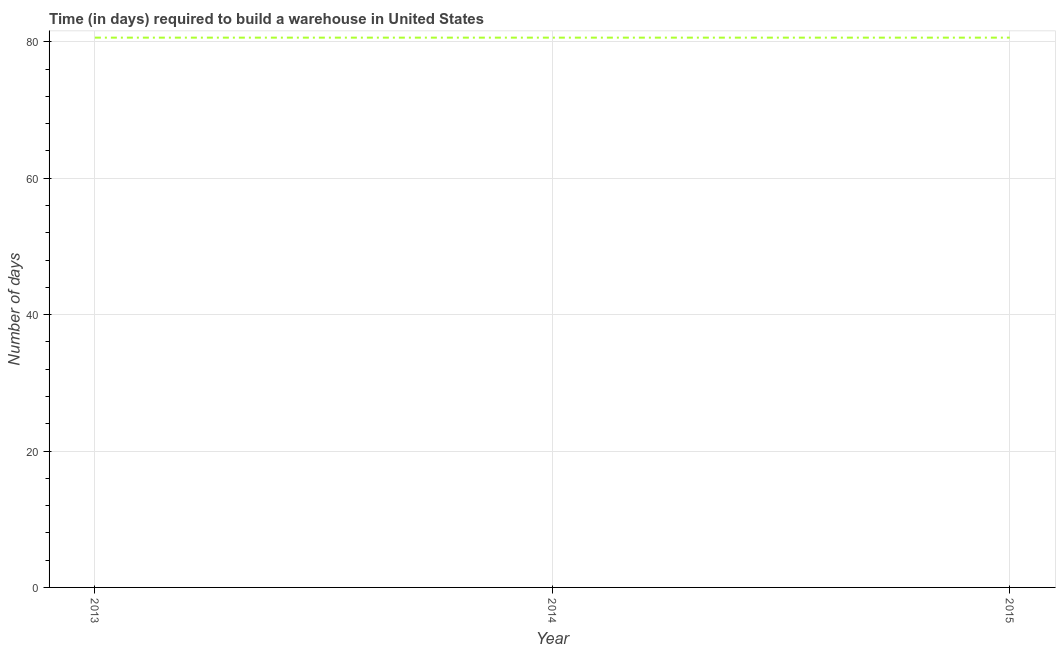What is the time required to build a warehouse in 2014?
Keep it short and to the point. 80.6. Across all years, what is the maximum time required to build a warehouse?
Your response must be concise. 80.6. Across all years, what is the minimum time required to build a warehouse?
Ensure brevity in your answer.  80.6. In which year was the time required to build a warehouse maximum?
Your response must be concise. 2013. What is the sum of the time required to build a warehouse?
Offer a terse response. 241.8. What is the difference between the time required to build a warehouse in 2013 and 2014?
Offer a terse response. 0. What is the average time required to build a warehouse per year?
Offer a very short reply. 80.6. What is the median time required to build a warehouse?
Your answer should be compact. 80.6. What is the difference between the highest and the second highest time required to build a warehouse?
Give a very brief answer. 0. In how many years, is the time required to build a warehouse greater than the average time required to build a warehouse taken over all years?
Make the answer very short. 0. How many lines are there?
Provide a succinct answer. 1. How many years are there in the graph?
Keep it short and to the point. 3. What is the difference between two consecutive major ticks on the Y-axis?
Give a very brief answer. 20. Are the values on the major ticks of Y-axis written in scientific E-notation?
Make the answer very short. No. Does the graph contain any zero values?
Your answer should be compact. No. What is the title of the graph?
Your response must be concise. Time (in days) required to build a warehouse in United States. What is the label or title of the Y-axis?
Offer a terse response. Number of days. What is the Number of days of 2013?
Provide a succinct answer. 80.6. What is the Number of days in 2014?
Your answer should be compact. 80.6. What is the Number of days in 2015?
Your answer should be compact. 80.6. What is the difference between the Number of days in 2013 and 2014?
Provide a short and direct response. 0. What is the difference between the Number of days in 2013 and 2015?
Give a very brief answer. 0. What is the difference between the Number of days in 2014 and 2015?
Offer a terse response. 0. What is the ratio of the Number of days in 2013 to that in 2014?
Your answer should be compact. 1. What is the ratio of the Number of days in 2013 to that in 2015?
Ensure brevity in your answer.  1. 